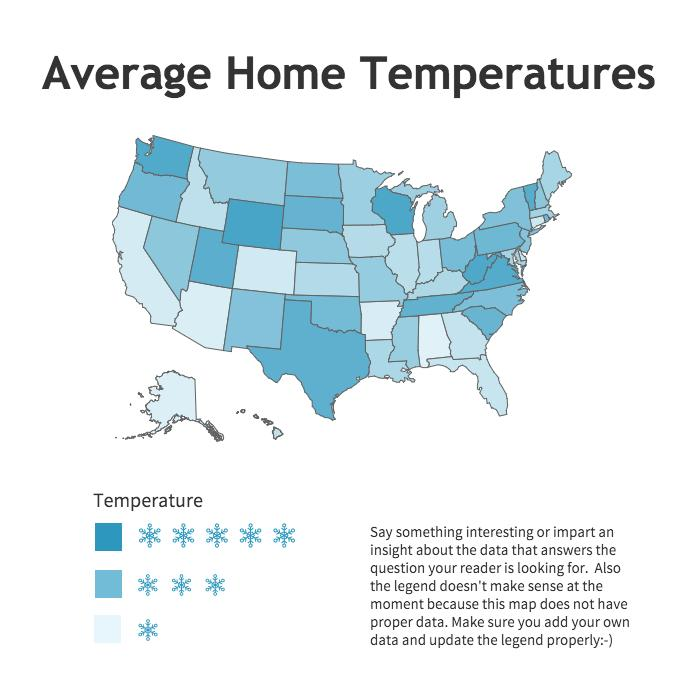Give some essential details in this illustration. The temperature ranges are shown in 3 different categories. 